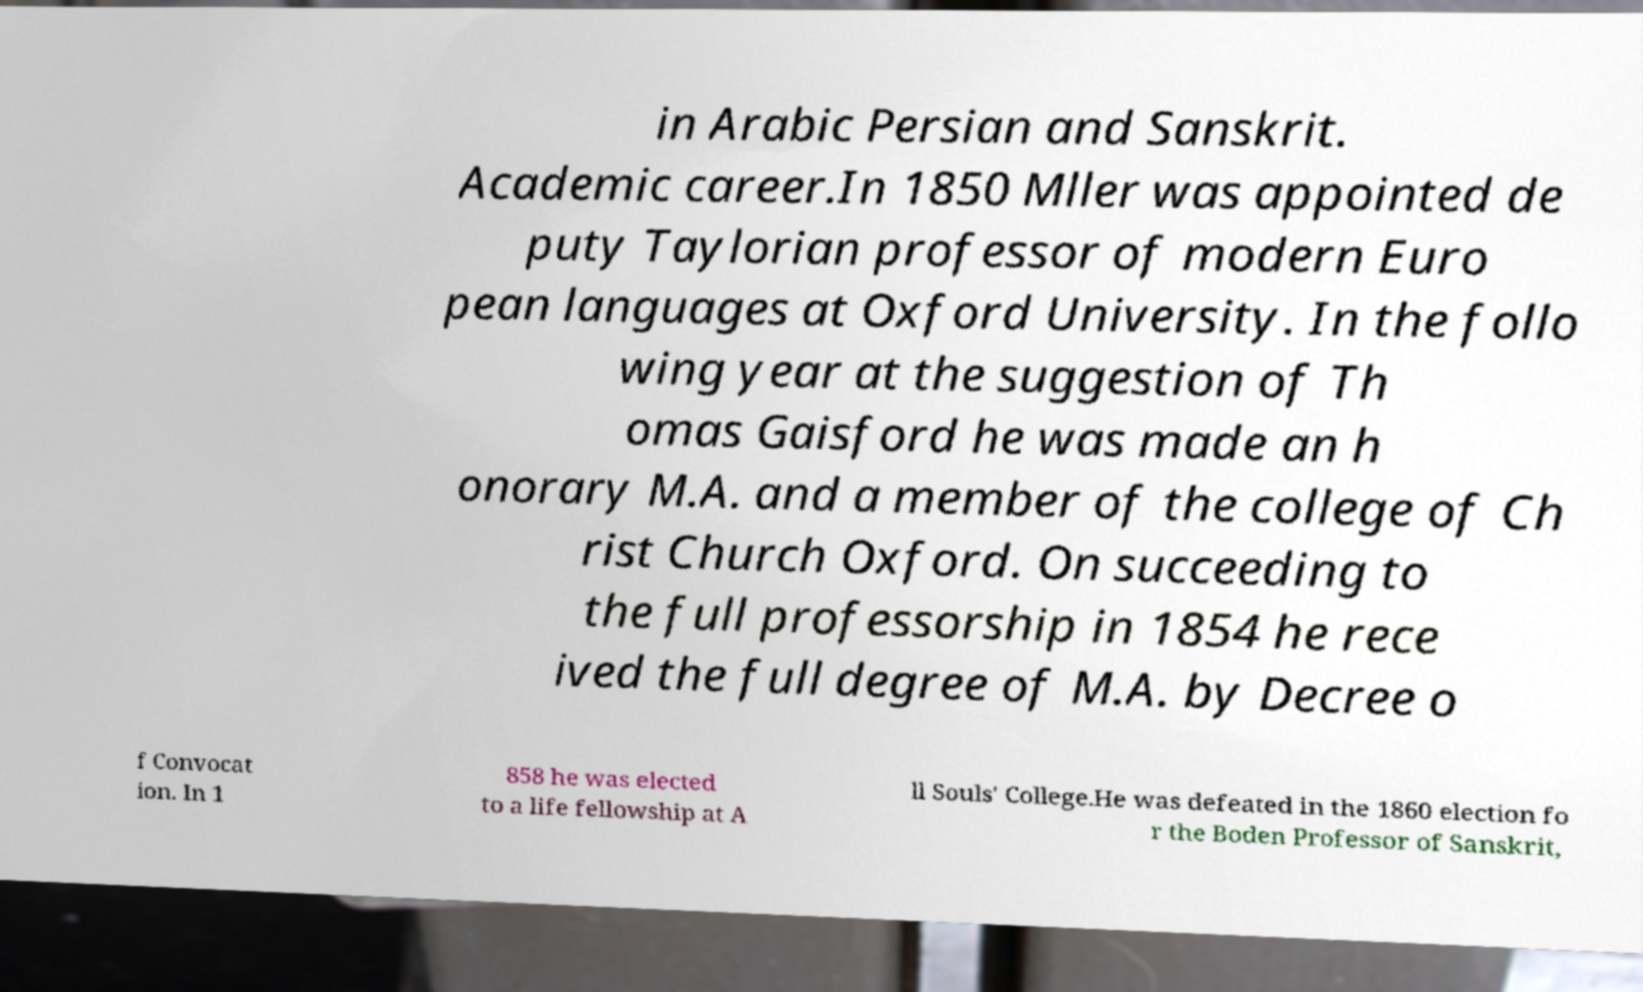Please identify and transcribe the text found in this image. in Arabic Persian and Sanskrit. Academic career.In 1850 Mller was appointed de puty Taylorian professor of modern Euro pean languages at Oxford University. In the follo wing year at the suggestion of Th omas Gaisford he was made an h onorary M.A. and a member of the college of Ch rist Church Oxford. On succeeding to the full professorship in 1854 he rece ived the full degree of M.A. by Decree o f Convocat ion. In 1 858 he was elected to a life fellowship at A ll Souls' College.He was defeated in the 1860 election fo r the Boden Professor of Sanskrit, 